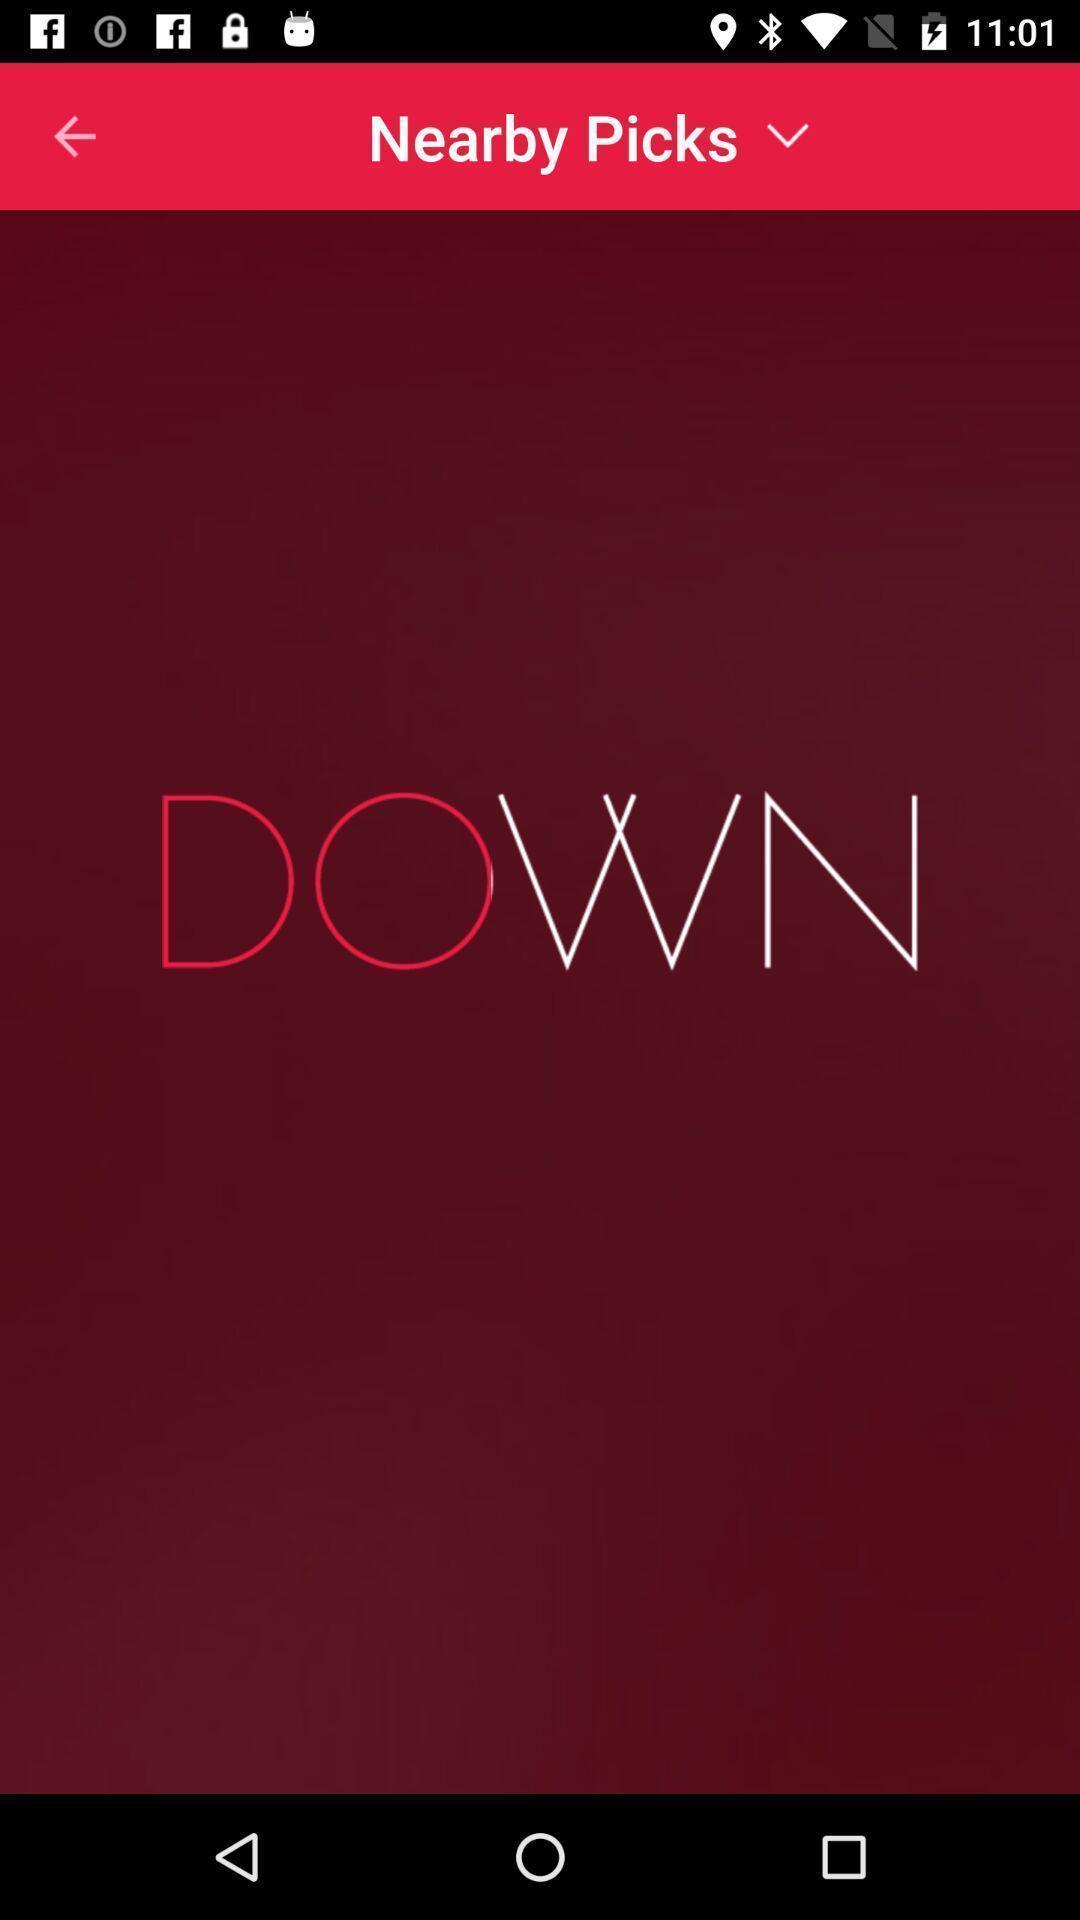What can you discern from this picture? Window displaying a dating app. 